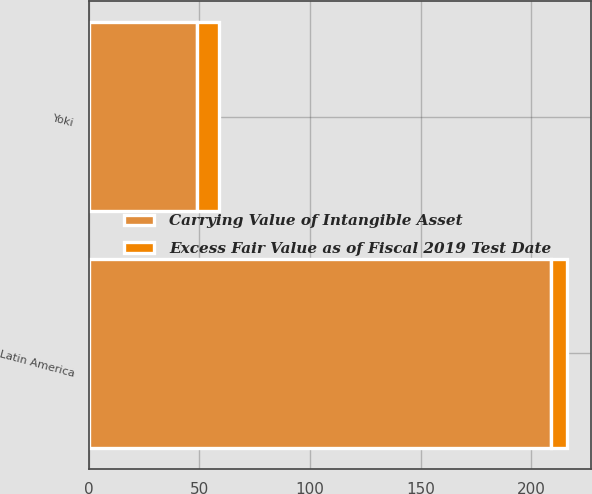Convert chart to OTSL. <chart><loc_0><loc_0><loc_500><loc_500><stacked_bar_chart><ecel><fcel>Latin America<fcel>Yoki<nl><fcel>Carrying Value of Intangible Asset<fcel>209<fcel>49.1<nl><fcel>Excess Fair Value as of Fiscal 2019 Test Date<fcel>7<fcel>10<nl></chart> 